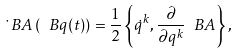Convert formula to latex. <formula><loc_0><loc_0><loc_500><loc_500>\dot { \ } B A \left ( \ B q ( t ) \right ) = \frac { 1 } { 2 } \left \{ \dot { q } ^ { k } , \frac { \partial } { \partial q ^ { k } } \ B A \right \} ,</formula> 